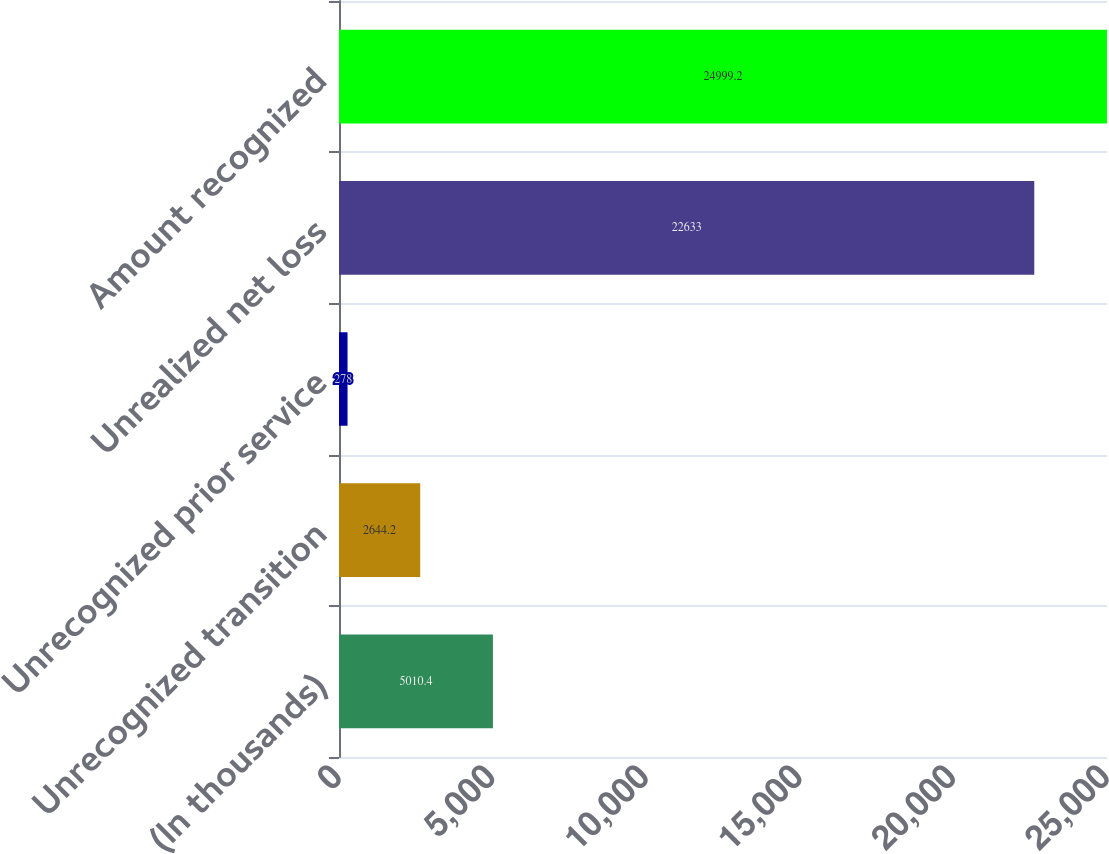Convert chart to OTSL. <chart><loc_0><loc_0><loc_500><loc_500><bar_chart><fcel>(In thousands)<fcel>Unrecognized transition<fcel>Unrecognized prior service<fcel>Unrealized net loss<fcel>Amount recognized<nl><fcel>5010.4<fcel>2644.2<fcel>278<fcel>22633<fcel>24999.2<nl></chart> 